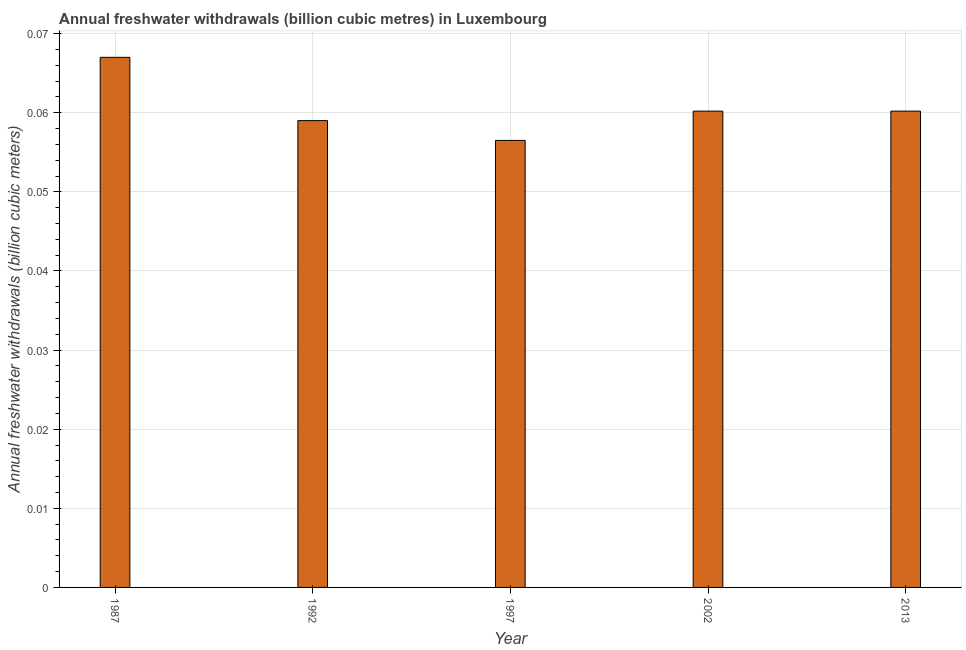What is the title of the graph?
Your answer should be compact. Annual freshwater withdrawals (billion cubic metres) in Luxembourg. What is the label or title of the Y-axis?
Make the answer very short. Annual freshwater withdrawals (billion cubic meters). What is the annual freshwater withdrawals in 1992?
Provide a short and direct response. 0.06. Across all years, what is the maximum annual freshwater withdrawals?
Offer a terse response. 0.07. Across all years, what is the minimum annual freshwater withdrawals?
Give a very brief answer. 0.06. In which year was the annual freshwater withdrawals maximum?
Make the answer very short. 1987. In which year was the annual freshwater withdrawals minimum?
Your response must be concise. 1997. What is the sum of the annual freshwater withdrawals?
Your answer should be compact. 0.3. What is the difference between the annual freshwater withdrawals in 1987 and 1997?
Your answer should be compact. 0.01. What is the average annual freshwater withdrawals per year?
Offer a very short reply. 0.06. What is the median annual freshwater withdrawals?
Keep it short and to the point. 0.06. What is the ratio of the annual freshwater withdrawals in 1992 to that in 1997?
Provide a short and direct response. 1.04. Is the annual freshwater withdrawals in 1992 less than that in 2013?
Offer a terse response. Yes. Is the difference between the annual freshwater withdrawals in 1997 and 2013 greater than the difference between any two years?
Ensure brevity in your answer.  No. What is the difference between the highest and the second highest annual freshwater withdrawals?
Give a very brief answer. 0.01. Is the sum of the annual freshwater withdrawals in 1987 and 2002 greater than the maximum annual freshwater withdrawals across all years?
Keep it short and to the point. Yes. In how many years, is the annual freshwater withdrawals greater than the average annual freshwater withdrawals taken over all years?
Ensure brevity in your answer.  1. How many bars are there?
Make the answer very short. 5. How many years are there in the graph?
Your response must be concise. 5. What is the difference between two consecutive major ticks on the Y-axis?
Your answer should be very brief. 0.01. What is the Annual freshwater withdrawals (billion cubic meters) of 1987?
Your answer should be compact. 0.07. What is the Annual freshwater withdrawals (billion cubic meters) of 1992?
Ensure brevity in your answer.  0.06. What is the Annual freshwater withdrawals (billion cubic meters) in 1997?
Offer a very short reply. 0.06. What is the Annual freshwater withdrawals (billion cubic meters) of 2002?
Your response must be concise. 0.06. What is the Annual freshwater withdrawals (billion cubic meters) in 2013?
Ensure brevity in your answer.  0.06. What is the difference between the Annual freshwater withdrawals (billion cubic meters) in 1987 and 1992?
Your response must be concise. 0.01. What is the difference between the Annual freshwater withdrawals (billion cubic meters) in 1987 and 1997?
Give a very brief answer. 0.01. What is the difference between the Annual freshwater withdrawals (billion cubic meters) in 1987 and 2002?
Provide a succinct answer. 0.01. What is the difference between the Annual freshwater withdrawals (billion cubic meters) in 1987 and 2013?
Offer a very short reply. 0.01. What is the difference between the Annual freshwater withdrawals (billion cubic meters) in 1992 and 1997?
Your response must be concise. 0. What is the difference between the Annual freshwater withdrawals (billion cubic meters) in 1992 and 2002?
Your answer should be compact. -0. What is the difference between the Annual freshwater withdrawals (billion cubic meters) in 1992 and 2013?
Make the answer very short. -0. What is the difference between the Annual freshwater withdrawals (billion cubic meters) in 1997 and 2002?
Give a very brief answer. -0. What is the difference between the Annual freshwater withdrawals (billion cubic meters) in 1997 and 2013?
Offer a terse response. -0. What is the difference between the Annual freshwater withdrawals (billion cubic meters) in 2002 and 2013?
Give a very brief answer. 0. What is the ratio of the Annual freshwater withdrawals (billion cubic meters) in 1987 to that in 1992?
Your answer should be very brief. 1.14. What is the ratio of the Annual freshwater withdrawals (billion cubic meters) in 1987 to that in 1997?
Your answer should be very brief. 1.19. What is the ratio of the Annual freshwater withdrawals (billion cubic meters) in 1987 to that in 2002?
Give a very brief answer. 1.11. What is the ratio of the Annual freshwater withdrawals (billion cubic meters) in 1987 to that in 2013?
Make the answer very short. 1.11. What is the ratio of the Annual freshwater withdrawals (billion cubic meters) in 1992 to that in 1997?
Give a very brief answer. 1.04. What is the ratio of the Annual freshwater withdrawals (billion cubic meters) in 1992 to that in 2002?
Provide a succinct answer. 0.98. What is the ratio of the Annual freshwater withdrawals (billion cubic meters) in 1997 to that in 2002?
Keep it short and to the point. 0.94. What is the ratio of the Annual freshwater withdrawals (billion cubic meters) in 1997 to that in 2013?
Your response must be concise. 0.94. 